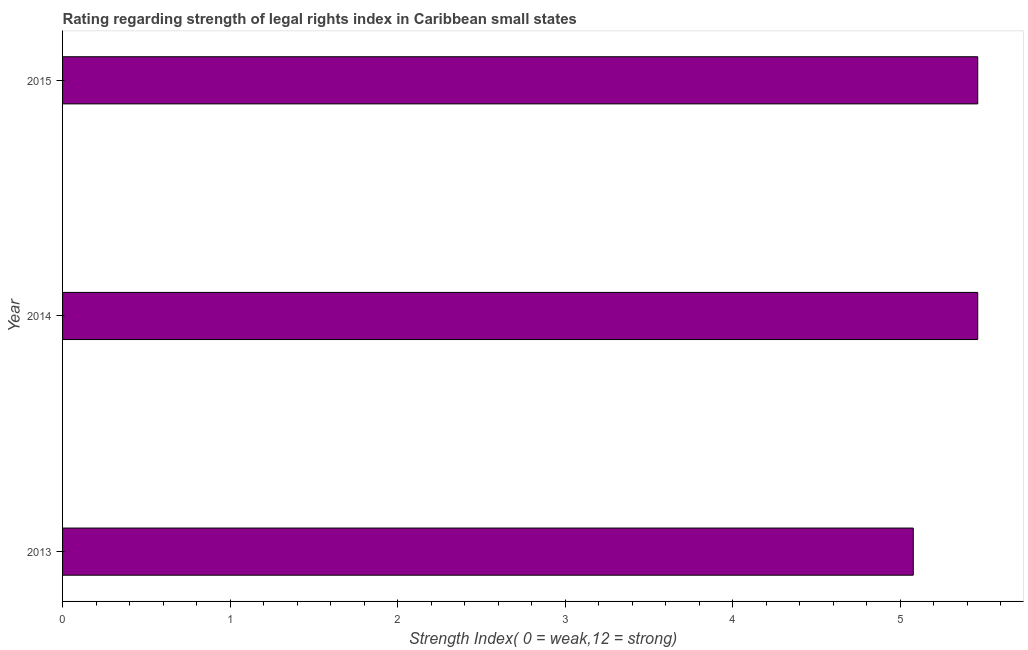Does the graph contain any zero values?
Keep it short and to the point. No. Does the graph contain grids?
Give a very brief answer. No. What is the title of the graph?
Ensure brevity in your answer.  Rating regarding strength of legal rights index in Caribbean small states. What is the label or title of the X-axis?
Offer a terse response. Strength Index( 0 = weak,12 = strong). What is the label or title of the Y-axis?
Offer a very short reply. Year. What is the strength of legal rights index in 2013?
Make the answer very short. 5.08. Across all years, what is the maximum strength of legal rights index?
Provide a succinct answer. 5.46. Across all years, what is the minimum strength of legal rights index?
Give a very brief answer. 5.08. In which year was the strength of legal rights index maximum?
Your answer should be very brief. 2014. What is the sum of the strength of legal rights index?
Give a very brief answer. 16. What is the difference between the strength of legal rights index in 2013 and 2014?
Keep it short and to the point. -0.39. What is the average strength of legal rights index per year?
Your answer should be compact. 5.33. What is the median strength of legal rights index?
Give a very brief answer. 5.46. In how many years, is the strength of legal rights index greater than 1.4 ?
Your answer should be compact. 3. Is the strength of legal rights index in 2013 less than that in 2014?
Give a very brief answer. Yes. What is the difference between the highest and the lowest strength of legal rights index?
Make the answer very short. 0.38. In how many years, is the strength of legal rights index greater than the average strength of legal rights index taken over all years?
Keep it short and to the point. 2. Are all the bars in the graph horizontal?
Your response must be concise. Yes. Are the values on the major ticks of X-axis written in scientific E-notation?
Offer a terse response. No. What is the Strength Index( 0 = weak,12 = strong) in 2013?
Your answer should be very brief. 5.08. What is the Strength Index( 0 = weak,12 = strong) in 2014?
Your answer should be very brief. 5.46. What is the Strength Index( 0 = weak,12 = strong) of 2015?
Your answer should be very brief. 5.46. What is the difference between the Strength Index( 0 = weak,12 = strong) in 2013 and 2014?
Your answer should be compact. -0.38. What is the difference between the Strength Index( 0 = weak,12 = strong) in 2013 and 2015?
Provide a succinct answer. -0.38. What is the ratio of the Strength Index( 0 = weak,12 = strong) in 2013 to that in 2014?
Your answer should be very brief. 0.93. What is the ratio of the Strength Index( 0 = weak,12 = strong) in 2013 to that in 2015?
Ensure brevity in your answer.  0.93. 